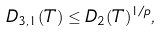<formula> <loc_0><loc_0><loc_500><loc_500>D _ { 3 , 1 } ( T ) \leq D _ { 2 } ( T ) ^ { 1 / p } ,</formula> 